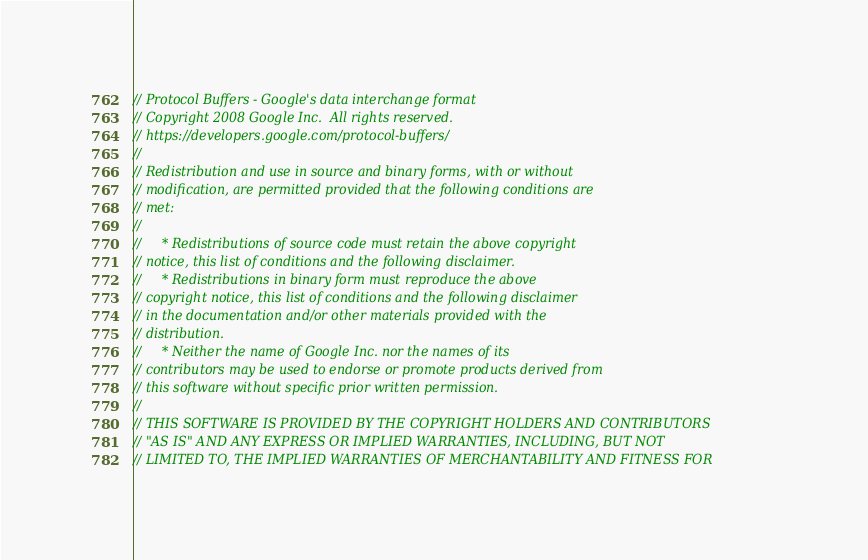Convert code to text. <code><loc_0><loc_0><loc_500><loc_500><_C++_>// Protocol Buffers - Google's data interchange format
// Copyright 2008 Google Inc.  All rights reserved.
// https://developers.google.com/protocol-buffers/
//
// Redistribution and use in source and binary forms, with or without
// modification, are permitted provided that the following conditions are
// met:
//
//     * Redistributions of source code must retain the above copyright
// notice, this list of conditions and the following disclaimer.
//     * Redistributions in binary form must reproduce the above
// copyright notice, this list of conditions and the following disclaimer
// in the documentation and/or other materials provided with the
// distribution.
//     * Neither the name of Google Inc. nor the names of its
// contributors may be used to endorse or promote products derived from
// this software without specific prior written permission.
//
// THIS SOFTWARE IS PROVIDED BY THE COPYRIGHT HOLDERS AND CONTRIBUTORS
// "AS IS" AND ANY EXPRESS OR IMPLIED WARRANTIES, INCLUDING, BUT NOT
// LIMITED TO, THE IMPLIED WARRANTIES OF MERCHANTABILITY AND FITNESS FOR</code> 